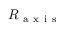Convert formula to latex. <formula><loc_0><loc_0><loc_500><loc_500>R _ { a x i s }</formula> 